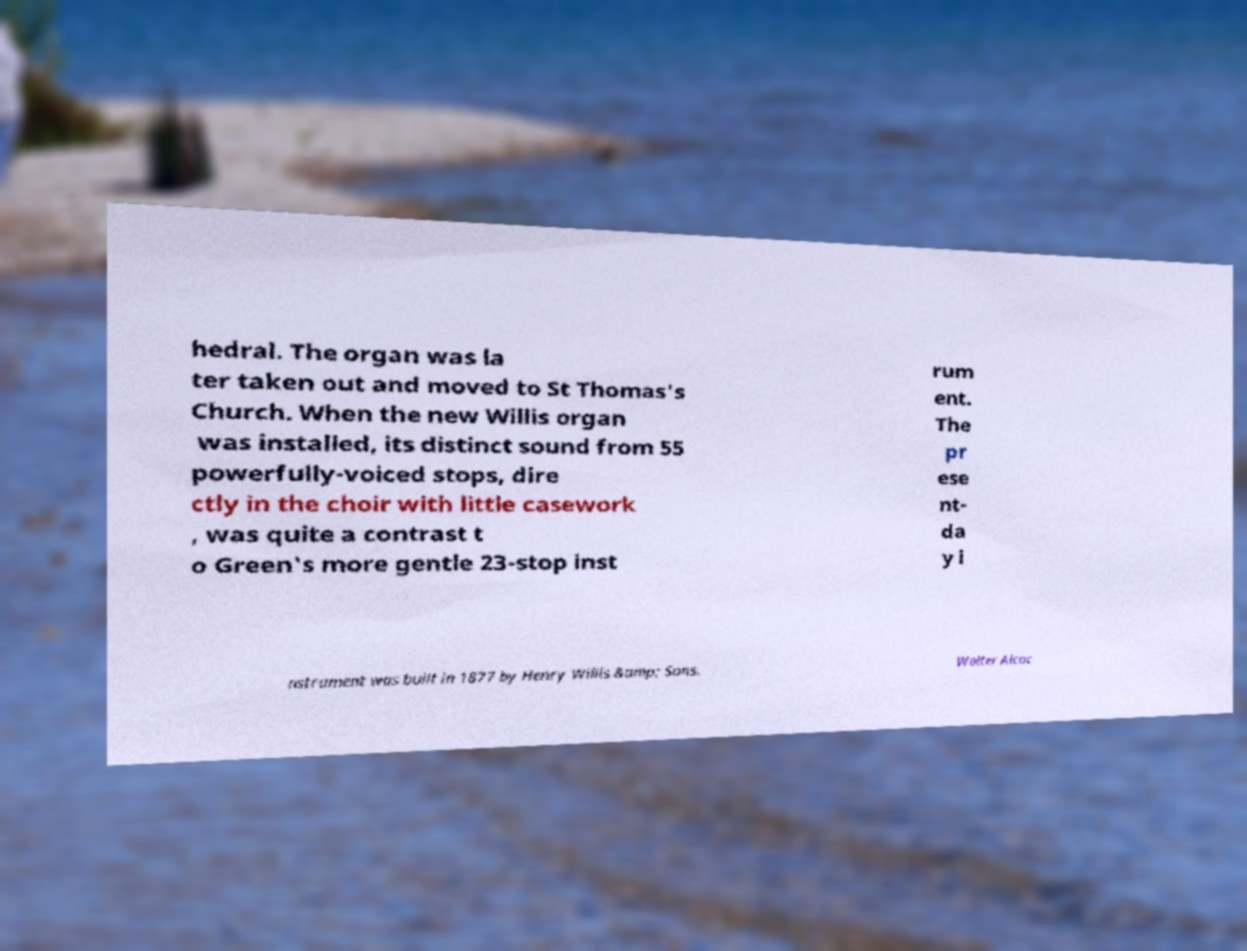I need the written content from this picture converted into text. Can you do that? hedral. The organ was la ter taken out and moved to St Thomas's Church. When the new Willis organ was installed, its distinct sound from 55 powerfully-voiced stops, dire ctly in the choir with little casework , was quite a contrast t o Green's more gentle 23-stop inst rum ent. The pr ese nt- da y i nstrument was built in 1877 by Henry Willis &amp; Sons. Walter Alcoc 